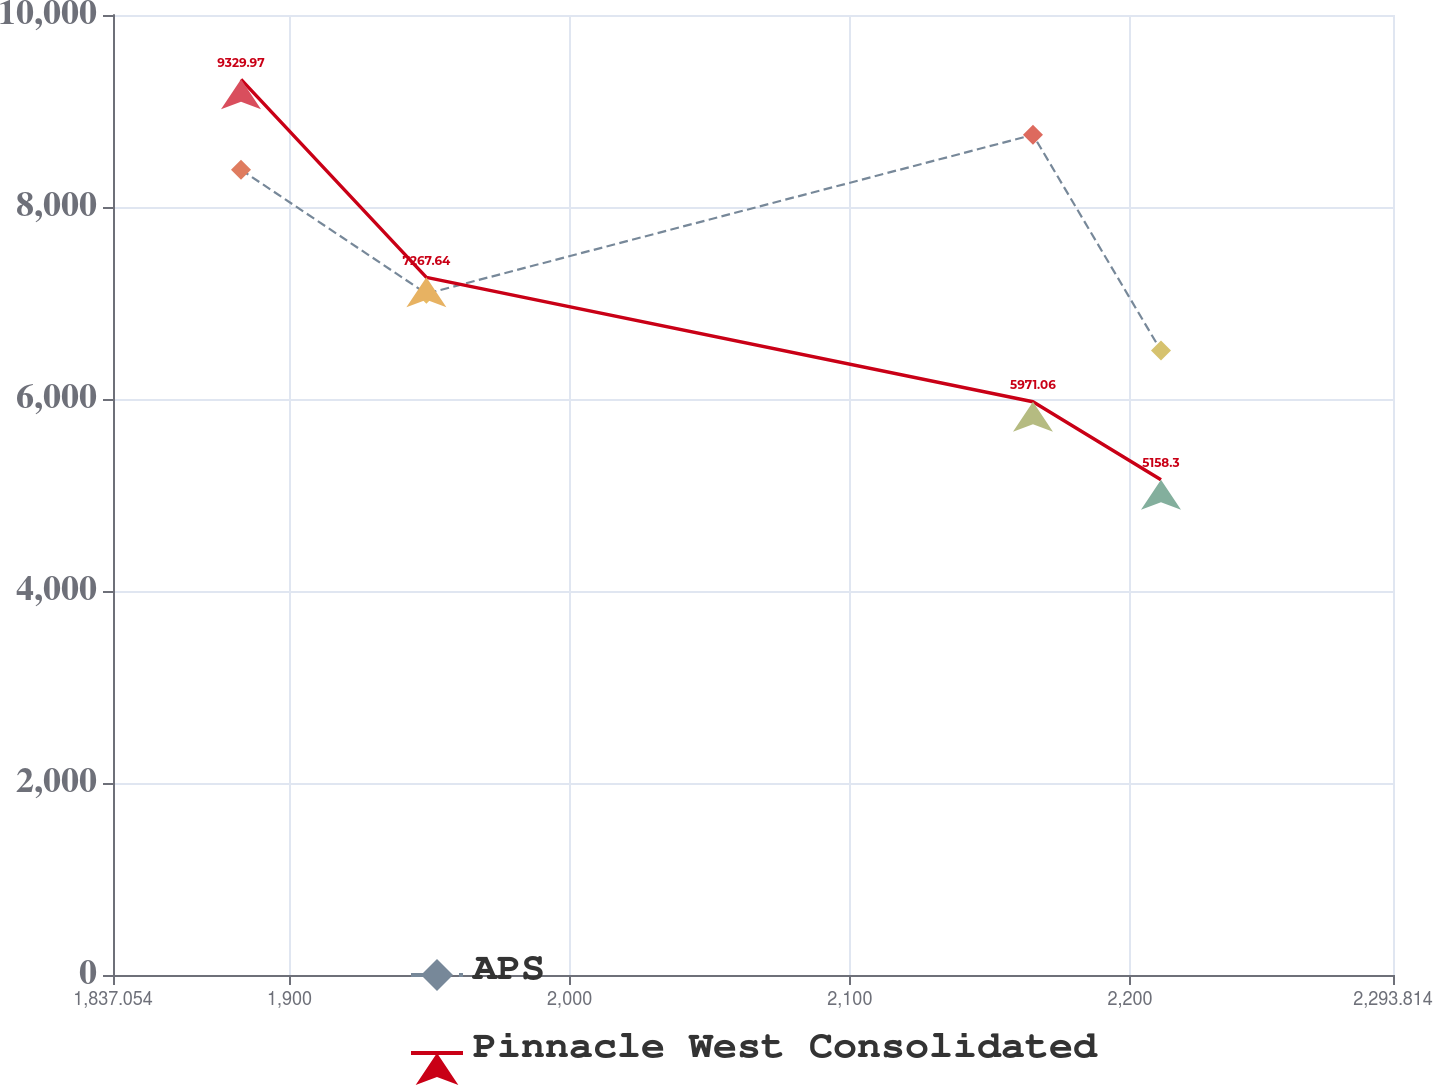Convert chart. <chart><loc_0><loc_0><loc_500><loc_500><line_chart><ecel><fcel>APS<fcel>Pinnacle West Consolidated<nl><fcel>1882.73<fcel>8387.91<fcel>9329.97<nl><fcel>1948.88<fcel>7097.41<fcel>7267.64<nl><fcel>2165.34<fcel>8751.88<fcel>5971.06<nl><fcel>2211.02<fcel>6503.94<fcel>5158.3<nl><fcel>2339.49<fcel>4769.95<fcel>4321.41<nl></chart> 